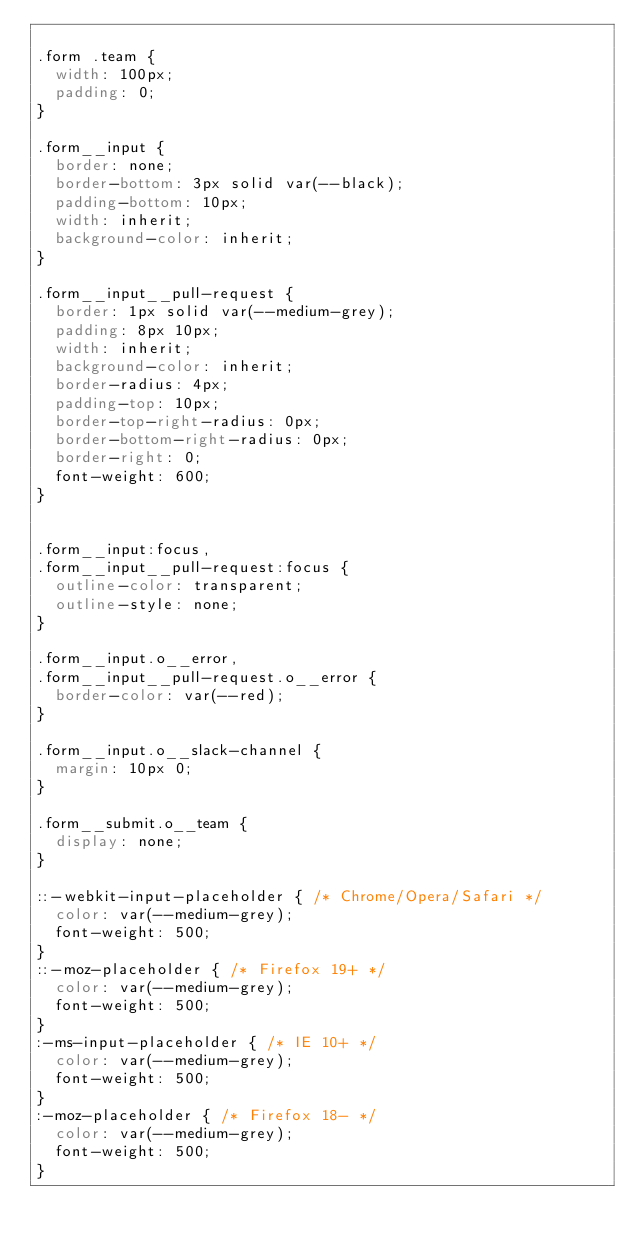<code> <loc_0><loc_0><loc_500><loc_500><_CSS_>
.form .team {
  width: 100px;
  padding: 0;
}

.form__input {
  border: none;
  border-bottom: 3px solid var(--black);
  padding-bottom: 10px;
  width: inherit;
  background-color: inherit;
}

.form__input__pull-request {
  border: 1px solid var(--medium-grey);
  padding: 8px 10px;
  width: inherit;
  background-color: inherit;
  border-radius: 4px;
  padding-top: 10px;
  border-top-right-radius: 0px;
  border-bottom-right-radius: 0px;
  border-right: 0;
  font-weight: 600;
}


.form__input:focus,
.form__input__pull-request:focus {
  outline-color: transparent;
  outline-style: none;
}

.form__input.o__error,
.form__input__pull-request.o__error {
  border-color: var(--red);
}

.form__input.o__slack-channel {
  margin: 10px 0;
}

.form__submit.o__team {
  display: none;
}

::-webkit-input-placeholder { /* Chrome/Opera/Safari */
  color: var(--medium-grey);
  font-weight: 500;
}
::-moz-placeholder { /* Firefox 19+ */
  color: var(--medium-grey);
  font-weight: 500;
}
:-ms-input-placeholder { /* IE 10+ */
  color: var(--medium-grey);
  font-weight: 500;
}
:-moz-placeholder { /* Firefox 18- */
  color: var(--medium-grey);
  font-weight: 500;
}
</code> 